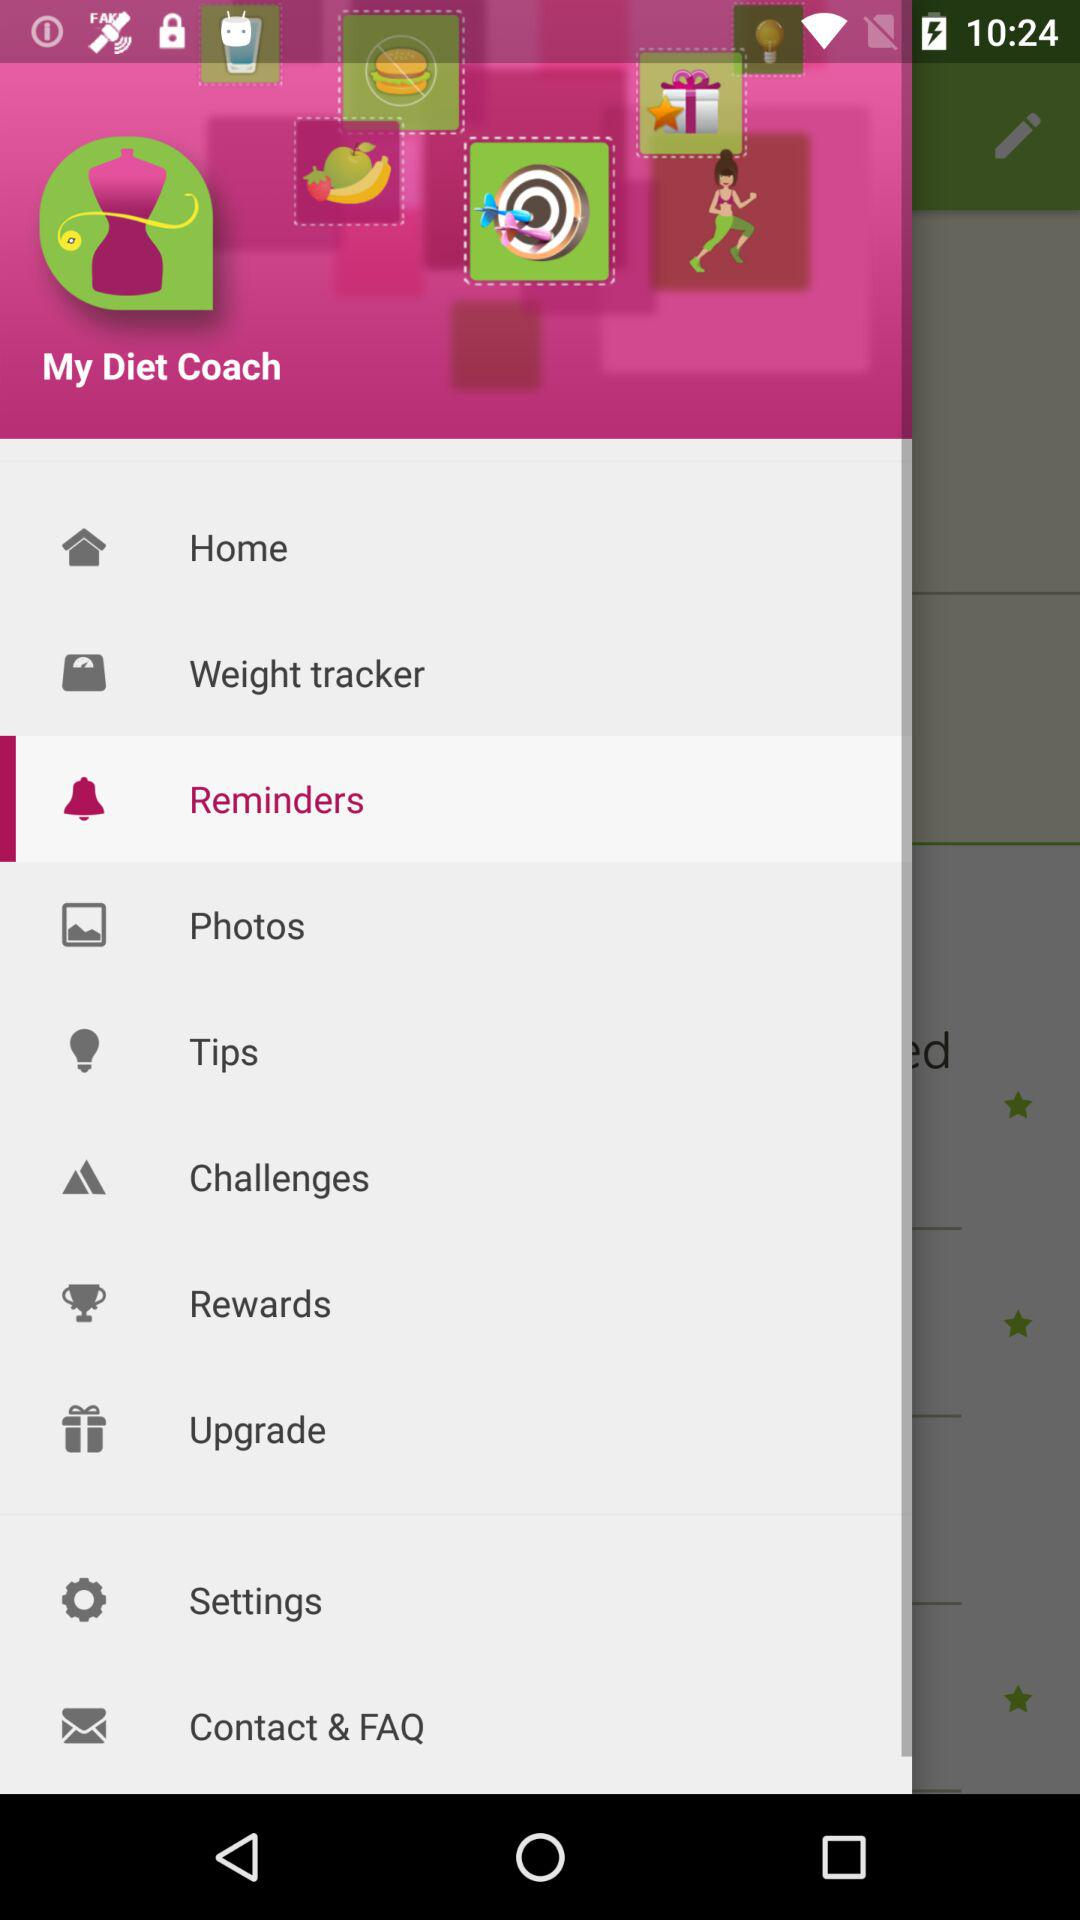What is the name of the application? The name of the application is "My Diet Coach". 